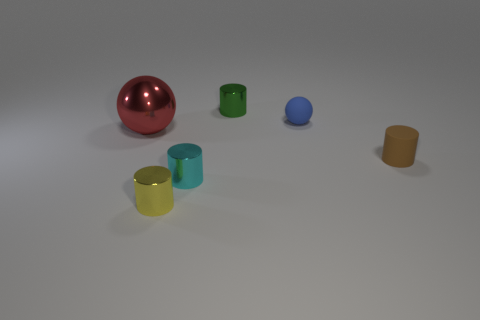Are there the same number of small green shiny things that are in front of the green metallic thing and yellow cylinders to the left of the tiny brown rubber cylinder?
Ensure brevity in your answer.  No. How many small blue matte objects are the same shape as the large shiny thing?
Offer a terse response. 1. Is there a small blue ball?
Offer a terse response. Yes. Is the brown thing made of the same material as the cylinder behind the large red metal object?
Your response must be concise. No. There is a yellow object that is the same size as the green cylinder; what is it made of?
Make the answer very short. Metal. Is there a small cyan object that has the same material as the tiny sphere?
Your answer should be very brief. No. There is a cyan cylinder on the left side of the small cylinder that is to the right of the green shiny cylinder; are there any blue spheres in front of it?
Give a very brief answer. No. There is a yellow metal thing that is the same size as the brown rubber object; what is its shape?
Give a very brief answer. Cylinder. Does the metallic thing behind the tiny blue matte thing have the same size as the sphere right of the large metallic sphere?
Provide a short and direct response. Yes. What number of small brown rubber spheres are there?
Make the answer very short. 0. 